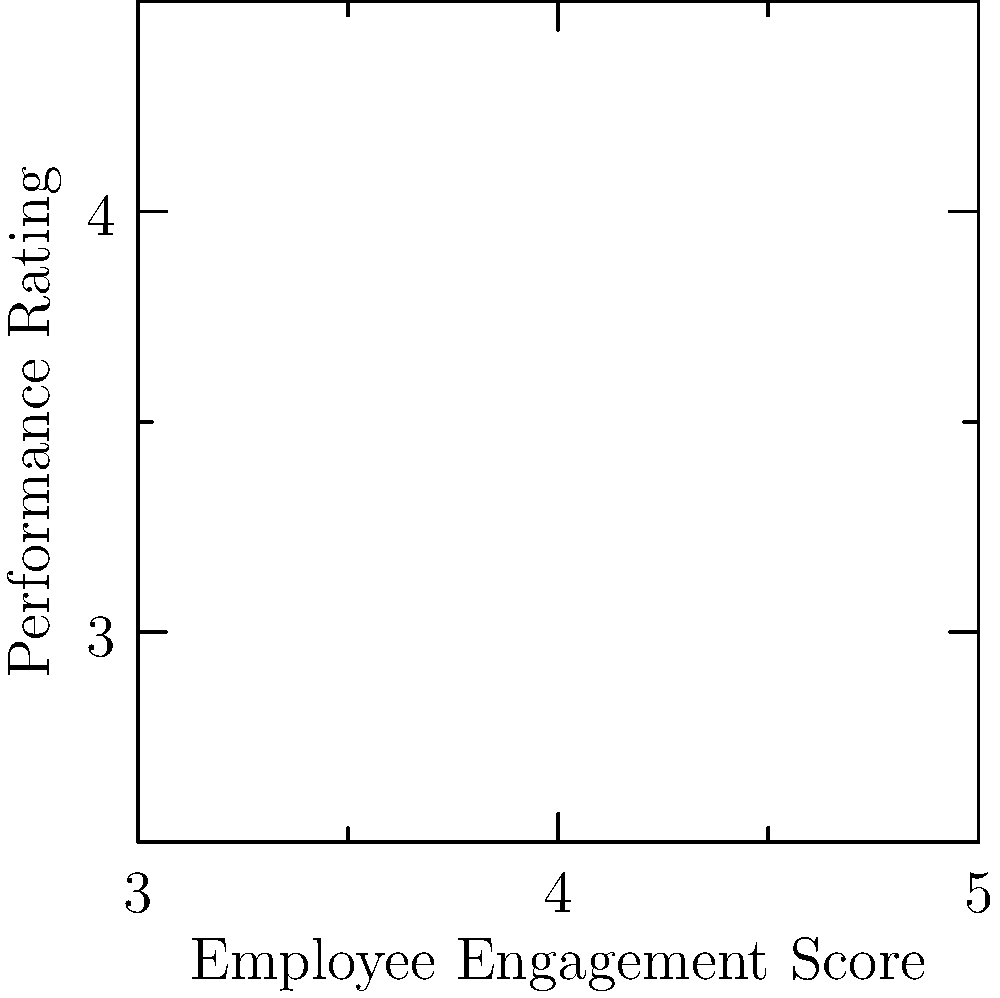Based on the bubble chart illustrating the correlation between employee engagement scores and performance ratings, what can be inferred about the relationship between these two variables? Additionally, what does the size of each bubble represent in this chart? To answer this question, let's analyze the bubble chart step by step:

1. Correlation:
   - The x-axis represents Employee Engagement Scores (ranging from 3 to 5).
   - The y-axis represents Performance Ratings (ranging from 2.5 to 4.5).
   - There is a clear positive correlation between the two variables, as indicated by the upward trend from left to right.
   - The red dashed line represents the general trend of the data points.

2. Strength of relationship:
   - The data points are closely clustered around the trend line, suggesting a strong positive correlation.
   - As employee engagement scores increase, performance ratings tend to increase as well.

3. Bubble size:
   - The size of each bubble varies, with larger bubbles representing a larger value for a third variable.
   - In an HR context, this third variable likely represents the size of the department or team.

4. Distribution:
   - The data points are spread across the range of both variables, providing a good representation of different engagement and performance levels.

5. Outliers:
   - There don't appear to be any significant outliers in the data set, which strengthens the observed relationship.

Based on this analysis, we can infer that there is a strong positive correlation between employee engagement scores and performance ratings. The size of each bubble likely represents the size of the department or team, providing additional context to the data points.
Answer: Strong positive correlation; bubble size represents department/team size 